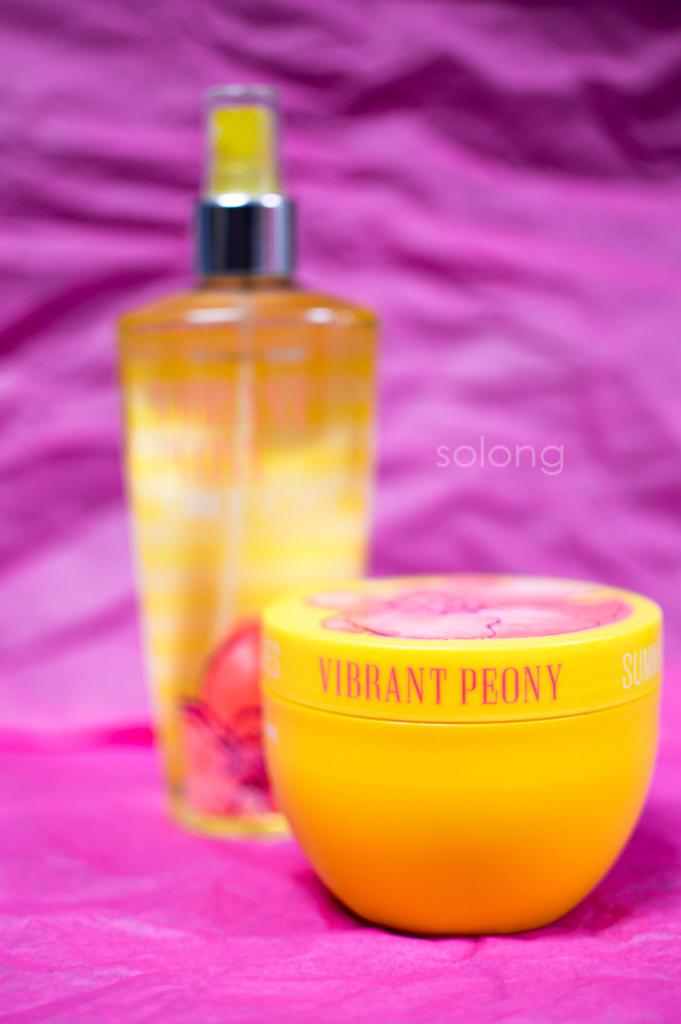What is the name of the product?
Your answer should be very brief. Vibrant peony. What is the watermark word?
Ensure brevity in your answer.  Solong. 